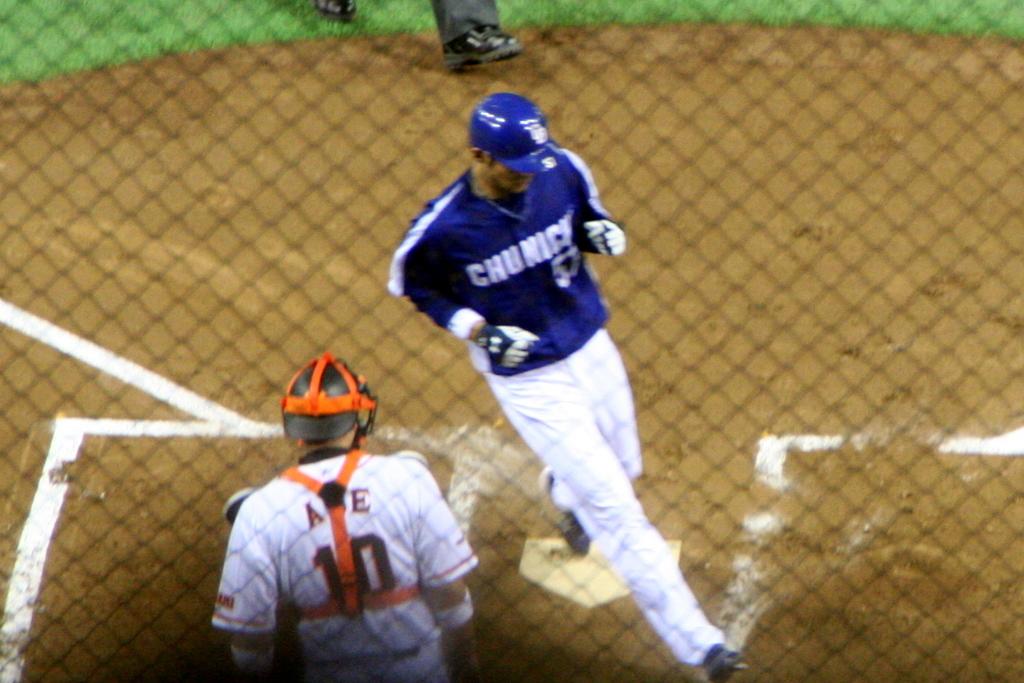What is the team the man in the blue shirt plays for?
Provide a short and direct response. Chunick. What is the number of the catcher?
Make the answer very short. 10. 